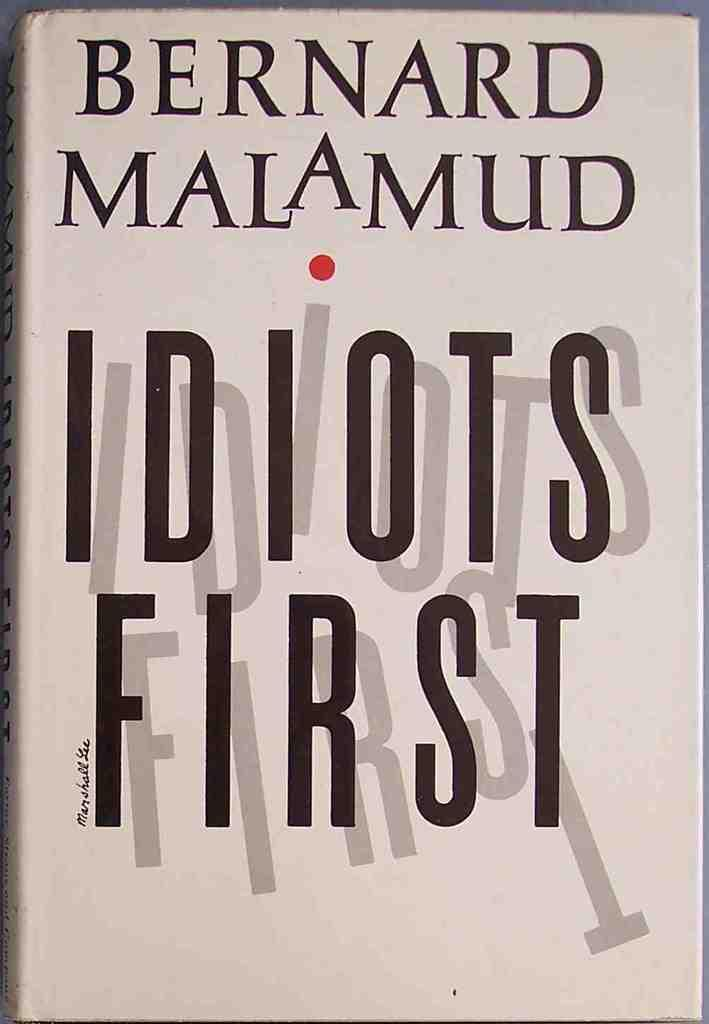<image>
Summarize the visual content of the image. The book Idiots First was written by Bernard Malamud and is available now. 